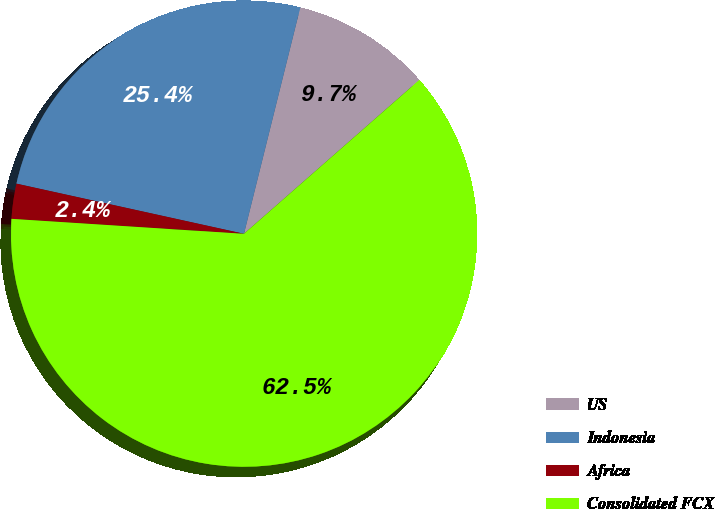Convert chart to OTSL. <chart><loc_0><loc_0><loc_500><loc_500><pie_chart><fcel>US<fcel>Indonesia<fcel>Africa<fcel>Consolidated FCX<nl><fcel>9.66%<fcel>25.43%<fcel>2.43%<fcel>62.49%<nl></chart> 